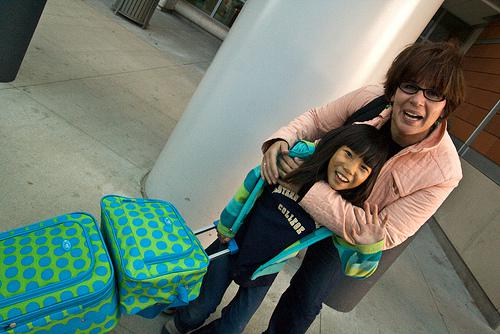Question: where was the picture taken?
Choices:
A. On a mountain.
B. At the zoo.
C. In the car.
D. On a sidewalk.
Answer with the letter. Answer: D Question: what is the girl doing?
Choices:
A. Waving.
B. Dancing.
C. Running.
D. Swinging.
Answer with the letter. Answer: A Question: what is she holding?
Choices:
A. Money.
B. A phone.
C. Bags.
D. Keys.
Answer with the letter. Answer: C Question: how many bags does she have?
Choices:
A. 2.
B. 1.
C. 3.
D. 4.
Answer with the letter. Answer: A 